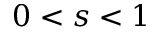Convert formula to latex. <formula><loc_0><loc_0><loc_500><loc_500>0 < s < 1</formula> 